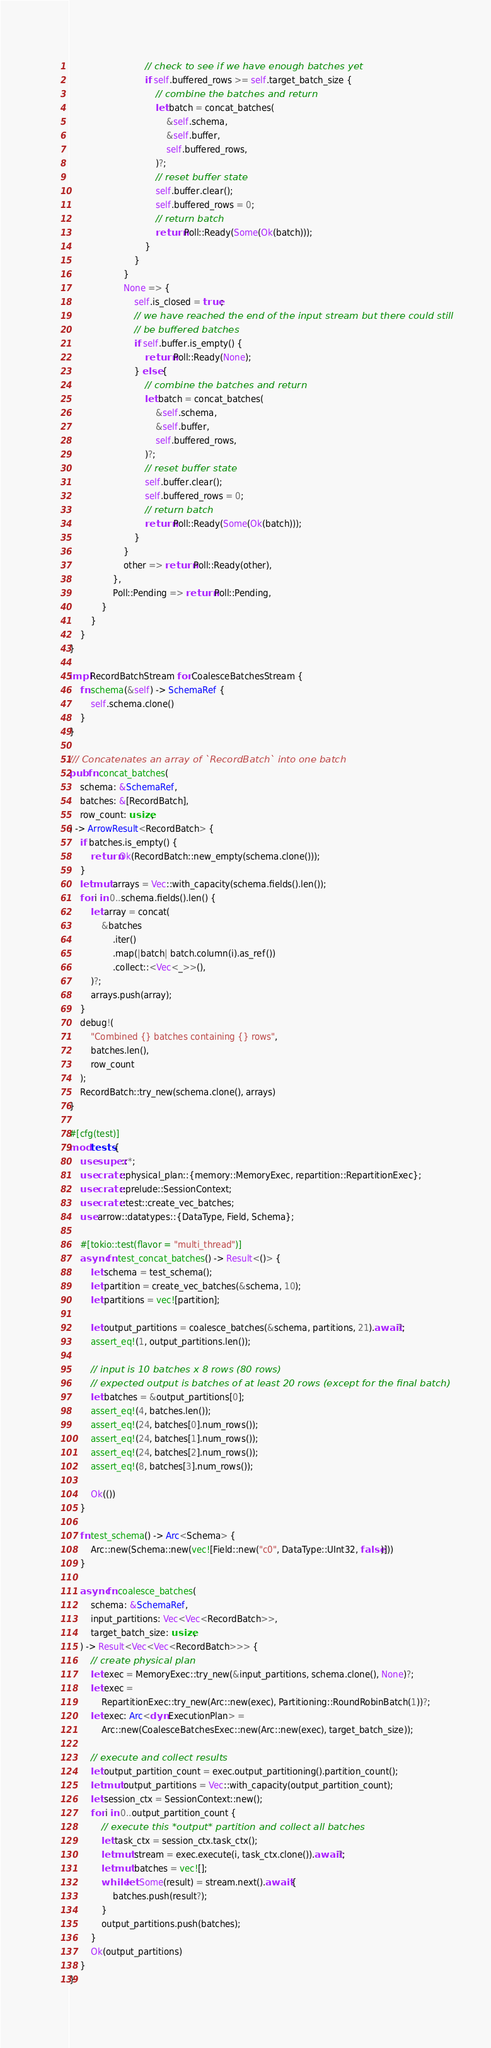Convert code to text. <code><loc_0><loc_0><loc_500><loc_500><_Rust_>                            // check to see if we have enough batches yet
                            if self.buffered_rows >= self.target_batch_size {
                                // combine the batches and return
                                let batch = concat_batches(
                                    &self.schema,
                                    &self.buffer,
                                    self.buffered_rows,
                                )?;
                                // reset buffer state
                                self.buffer.clear();
                                self.buffered_rows = 0;
                                // return batch
                                return Poll::Ready(Some(Ok(batch)));
                            }
                        }
                    }
                    None => {
                        self.is_closed = true;
                        // we have reached the end of the input stream but there could still
                        // be buffered batches
                        if self.buffer.is_empty() {
                            return Poll::Ready(None);
                        } else {
                            // combine the batches and return
                            let batch = concat_batches(
                                &self.schema,
                                &self.buffer,
                                self.buffered_rows,
                            )?;
                            // reset buffer state
                            self.buffer.clear();
                            self.buffered_rows = 0;
                            // return batch
                            return Poll::Ready(Some(Ok(batch)));
                        }
                    }
                    other => return Poll::Ready(other),
                },
                Poll::Pending => return Poll::Pending,
            }
        }
    }
}

impl RecordBatchStream for CoalesceBatchesStream {
    fn schema(&self) -> SchemaRef {
        self.schema.clone()
    }
}

/// Concatenates an array of `RecordBatch` into one batch
pub fn concat_batches(
    schema: &SchemaRef,
    batches: &[RecordBatch],
    row_count: usize,
) -> ArrowResult<RecordBatch> {
    if batches.is_empty() {
        return Ok(RecordBatch::new_empty(schema.clone()));
    }
    let mut arrays = Vec::with_capacity(schema.fields().len());
    for i in 0..schema.fields().len() {
        let array = concat(
            &batches
                .iter()
                .map(|batch| batch.column(i).as_ref())
                .collect::<Vec<_>>(),
        )?;
        arrays.push(array);
    }
    debug!(
        "Combined {} batches containing {} rows",
        batches.len(),
        row_count
    );
    RecordBatch::try_new(schema.clone(), arrays)
}

#[cfg(test)]
mod tests {
    use super::*;
    use crate::physical_plan::{memory::MemoryExec, repartition::RepartitionExec};
    use crate::prelude::SessionContext;
    use crate::test::create_vec_batches;
    use arrow::datatypes::{DataType, Field, Schema};

    #[tokio::test(flavor = "multi_thread")]
    async fn test_concat_batches() -> Result<()> {
        let schema = test_schema();
        let partition = create_vec_batches(&schema, 10);
        let partitions = vec![partition];

        let output_partitions = coalesce_batches(&schema, partitions, 21).await?;
        assert_eq!(1, output_partitions.len());

        // input is 10 batches x 8 rows (80 rows)
        // expected output is batches of at least 20 rows (except for the final batch)
        let batches = &output_partitions[0];
        assert_eq!(4, batches.len());
        assert_eq!(24, batches[0].num_rows());
        assert_eq!(24, batches[1].num_rows());
        assert_eq!(24, batches[2].num_rows());
        assert_eq!(8, batches[3].num_rows());

        Ok(())
    }

    fn test_schema() -> Arc<Schema> {
        Arc::new(Schema::new(vec![Field::new("c0", DataType::UInt32, false)]))
    }

    async fn coalesce_batches(
        schema: &SchemaRef,
        input_partitions: Vec<Vec<RecordBatch>>,
        target_batch_size: usize,
    ) -> Result<Vec<Vec<RecordBatch>>> {
        // create physical plan
        let exec = MemoryExec::try_new(&input_partitions, schema.clone(), None)?;
        let exec =
            RepartitionExec::try_new(Arc::new(exec), Partitioning::RoundRobinBatch(1))?;
        let exec: Arc<dyn ExecutionPlan> =
            Arc::new(CoalesceBatchesExec::new(Arc::new(exec), target_batch_size));

        // execute and collect results
        let output_partition_count = exec.output_partitioning().partition_count();
        let mut output_partitions = Vec::with_capacity(output_partition_count);
        let session_ctx = SessionContext::new();
        for i in 0..output_partition_count {
            // execute this *output* partition and collect all batches
            let task_ctx = session_ctx.task_ctx();
            let mut stream = exec.execute(i, task_ctx.clone()).await?;
            let mut batches = vec![];
            while let Some(result) = stream.next().await {
                batches.push(result?);
            }
            output_partitions.push(batches);
        }
        Ok(output_partitions)
    }
}
</code> 